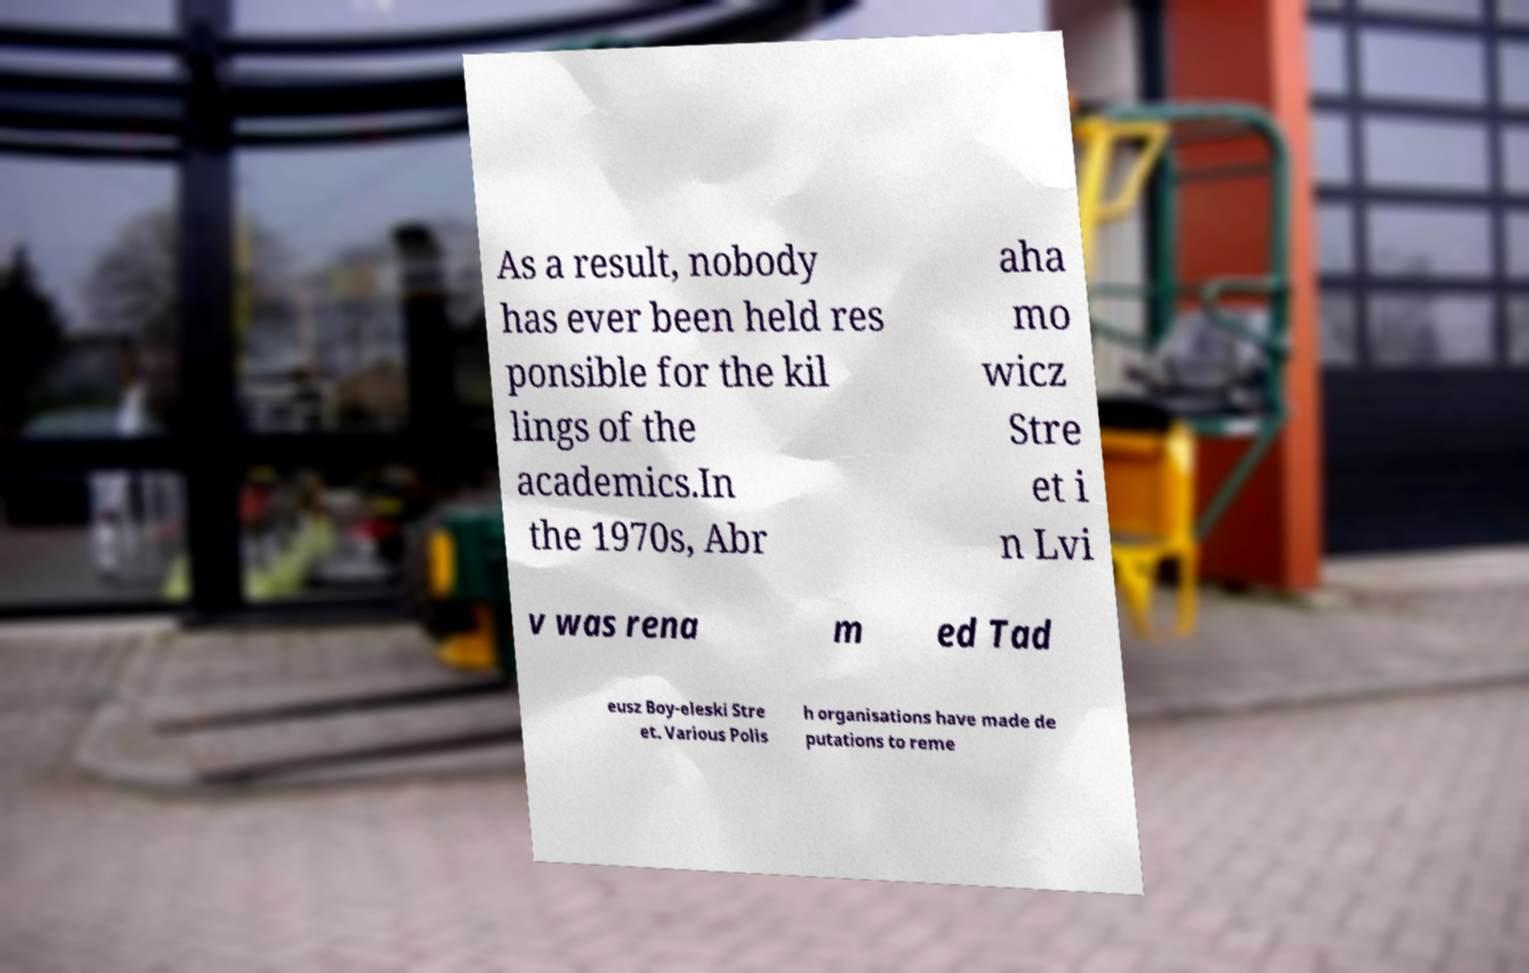Could you assist in decoding the text presented in this image and type it out clearly? As a result, nobody has ever been held res ponsible for the kil lings of the academics.In the 1970s, Abr aha mo wicz Stre et i n Lvi v was rena m ed Tad eusz Boy-eleski Stre et. Various Polis h organisations have made de putations to reme 